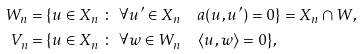<formula> <loc_0><loc_0><loc_500><loc_500>W _ { n } & = \{ u \in X _ { n } \ \colon \ \forall u ^ { \prime } \in X _ { n } \quad a ( u , u ^ { \prime } ) = 0 \} = X _ { n } \cap W , \\ V _ { n } & = \{ u \in X _ { n } \ \colon \ \forall w \in W _ { n } \quad \langle u , w \rangle = 0 \} ,</formula> 